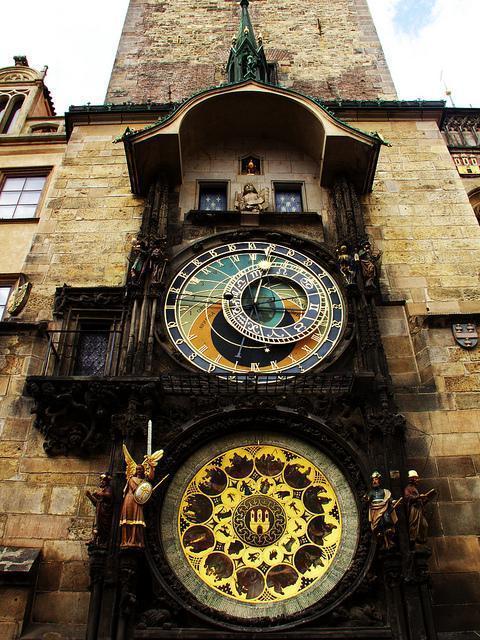How many 'guards' are next to the lower circle?
Give a very brief answer. 3. 